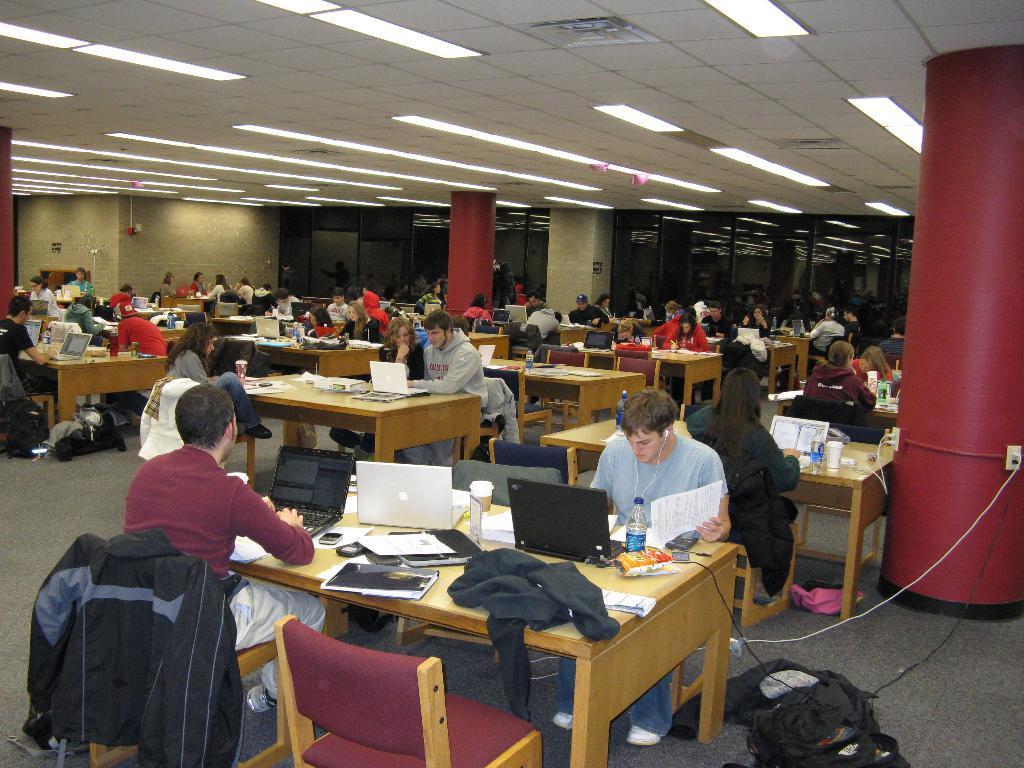Describe this image in one or two sentences. This picture is clicked inside a room. There are many chairs and tables in the images. There are people sitting on chairs. On the table there are laptops, bottles, books, mobile phones and jackets. There are lights to the ceiling. In the background there is wall and glass windows. 